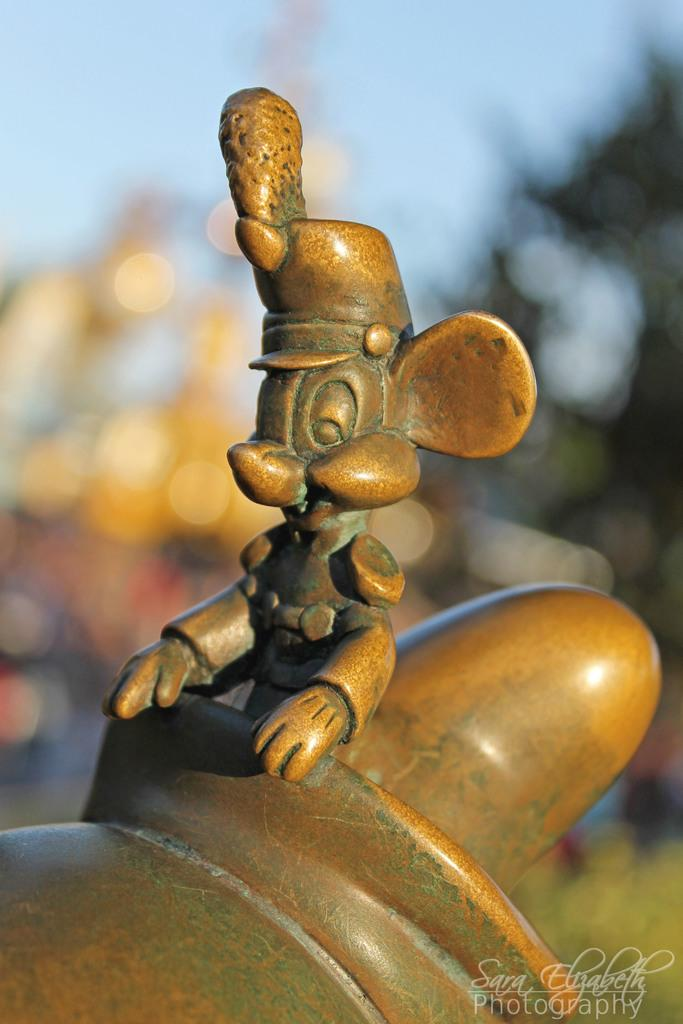What is the main subject of the image? There is a wooden sculpture in the image. Where is the wooden sculpture located in the image? The wooden sculpture is in the middle of the image. Can you describe any additional features of the image? There is a watermark at the bottom right corner of the image. How many children are playing in the snow around the wooden sculpture in the image? There are no children or snow present in the image; it only features a wooden sculpture and a watermark. 